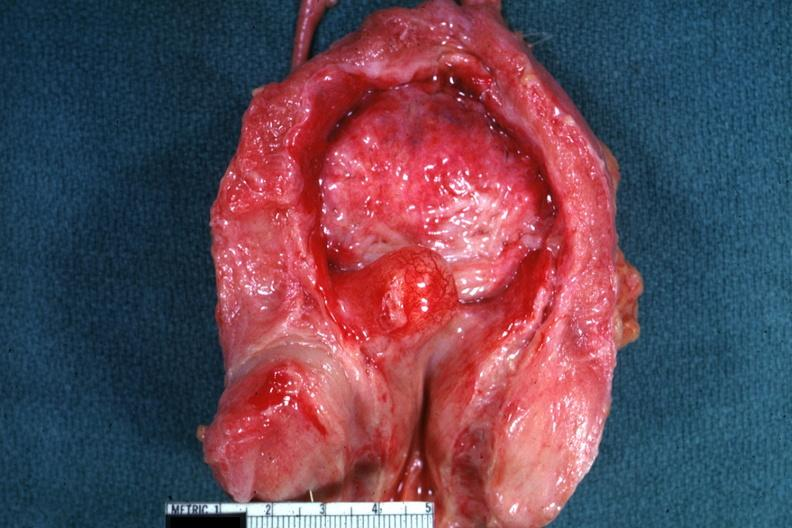what is present?
Answer the question using a single word or phrase. Prostate 